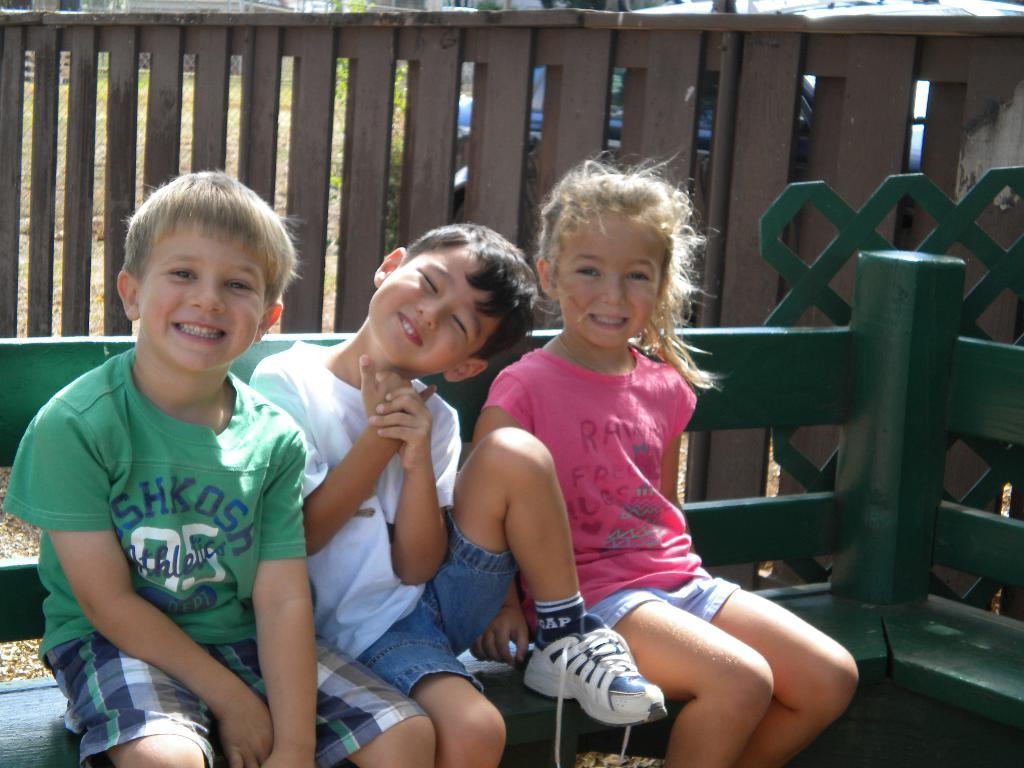How many children are in the image? There are three children in the image. What are the children doing in the image? The children are sitting on a bench. What type of clothing are the children wearing? The children are wearing t-shirts and shorts. What is the emotional expression of the children in the image? The children are smiling. What can be seen in the background of the image? There is a wooden fence in the background of the image. What is the reason behind the children rubbing their thumbs in the image? There is no indication in the image that the children are rubbing their thumbs, and therefore no such activity can be observed. 